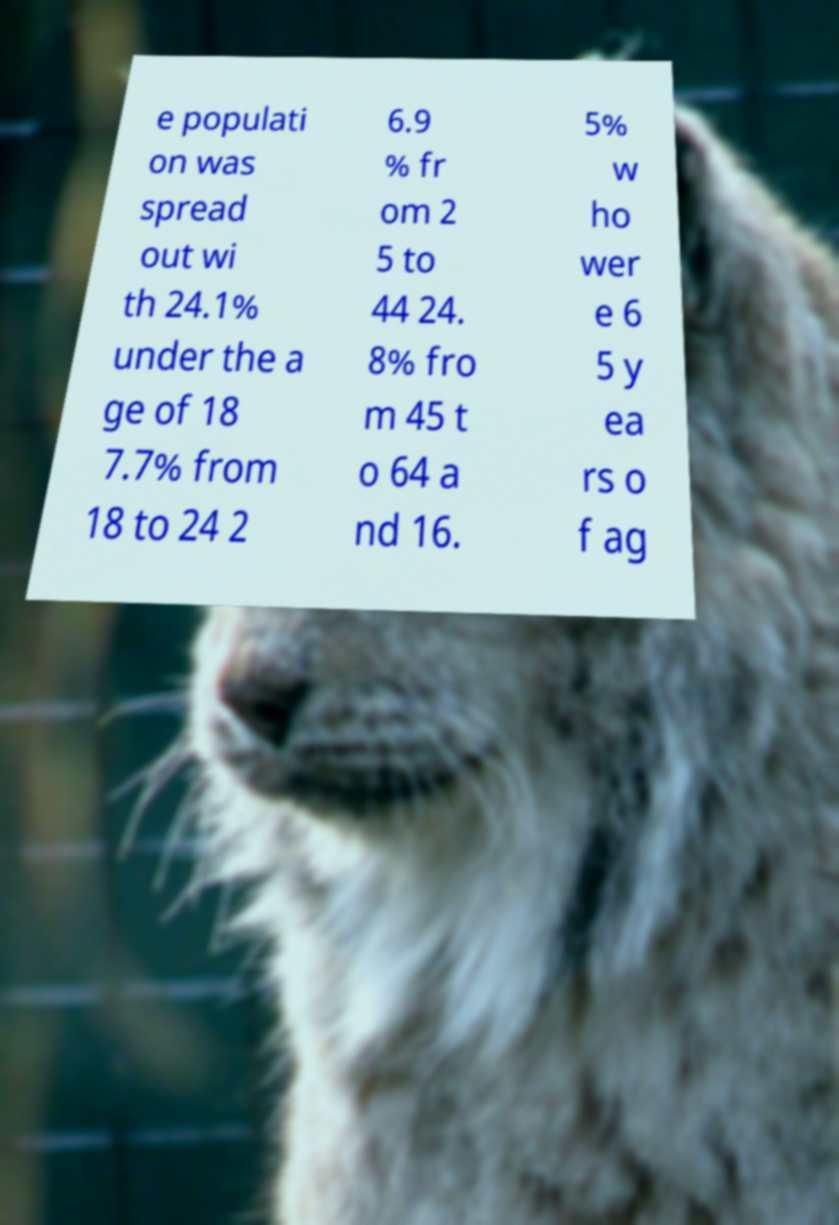Could you assist in decoding the text presented in this image and type it out clearly? e populati on was spread out wi th 24.1% under the a ge of 18 7.7% from 18 to 24 2 6.9 % fr om 2 5 to 44 24. 8% fro m 45 t o 64 a nd 16. 5% w ho wer e 6 5 y ea rs o f ag 